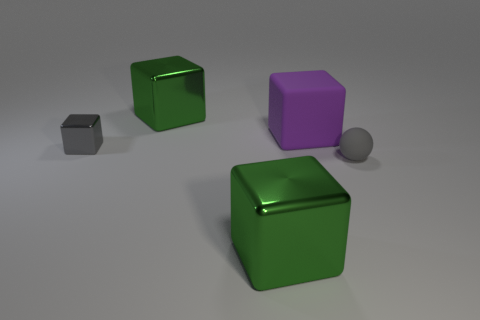What shape is the matte object that is the same size as the gray metal object?
Offer a terse response. Sphere. How many things are either objects that are in front of the tiny matte object or green shiny things that are in front of the big purple matte cube?
Make the answer very short. 1. There is a block that is the same size as the sphere; what is it made of?
Ensure brevity in your answer.  Metal. How many other objects are there of the same material as the ball?
Keep it short and to the point. 1. Are there the same number of large objects in front of the matte ball and large matte objects that are to the right of the large purple cube?
Give a very brief answer. No. What number of brown objects are either small rubber cylinders or metallic blocks?
Ensure brevity in your answer.  0. Do the large matte cube and the cube in front of the small metal object have the same color?
Ensure brevity in your answer.  No. What number of other things are the same color as the small metal thing?
Provide a succinct answer. 1. Is the number of big purple matte blocks less than the number of big green metal cubes?
Provide a succinct answer. Yes. There is a large green cube that is in front of the tiny sphere that is right of the purple rubber cube; what number of metal cubes are to the left of it?
Your response must be concise. 2. 